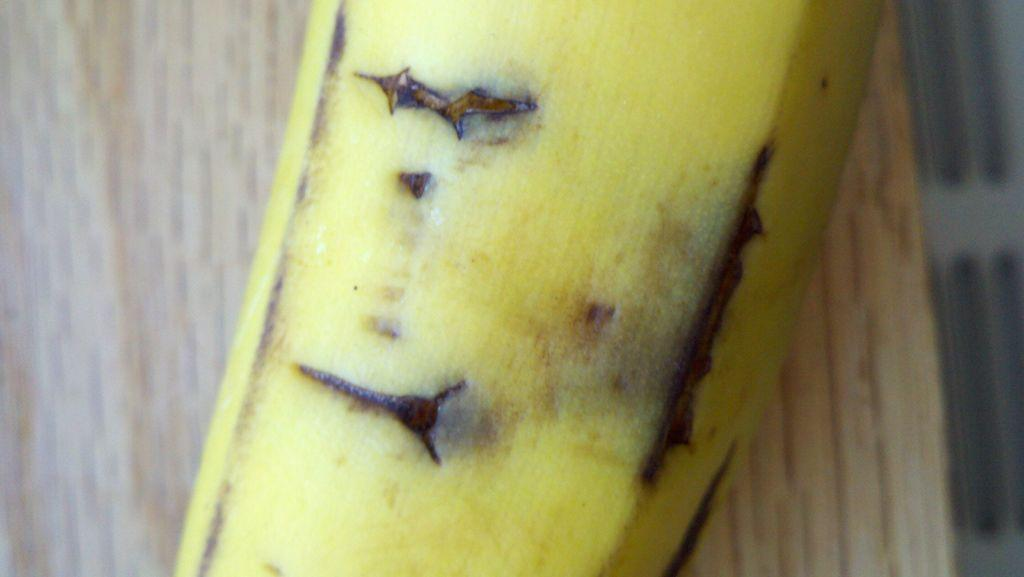What is the main subject of the image? The main subject of the image is a truncated banana. Where is the banana located in the image? The banana is on a wooden surface. What type of snow can be seen falling in the image? There is no snow present in the image; it features a truncated banana on a wooden surface. What type of birthday celebration is depicted in the image? There is no birthday celebration depicted in the image; it only shows a truncated banana on a wooden surface. 